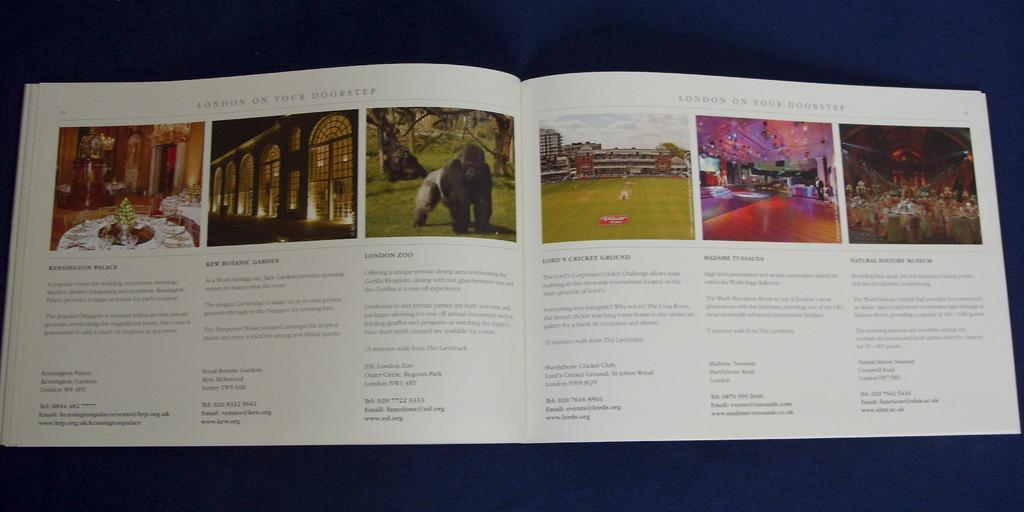<image>
Present a compact description of the photo's key features. Opened book on a page titled "London On Your Doorstep". 